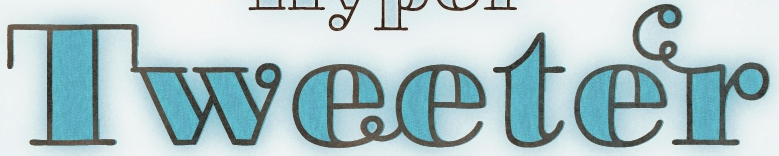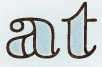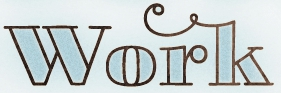Identify the words shown in these images in order, separated by a semicolon. Tweeter; at; work 